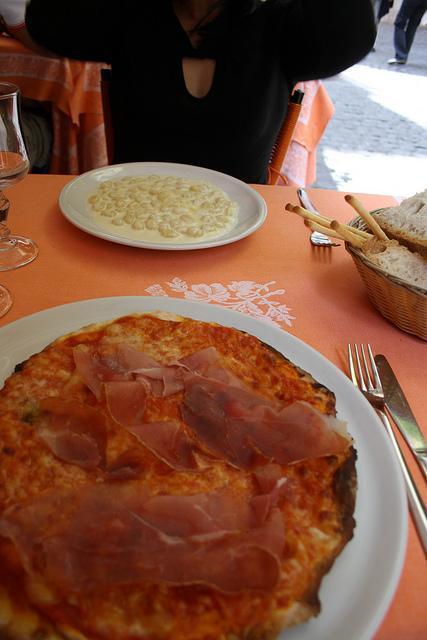What are the sticks seen here made from?
Indicate the correct response and explain using: 'Answer: answer
Rationale: rationale.'
Options: Bread, drumsticks, chicken, beef. Answer: bread.
Rationale: These are breadsticks that are a side with dinner 